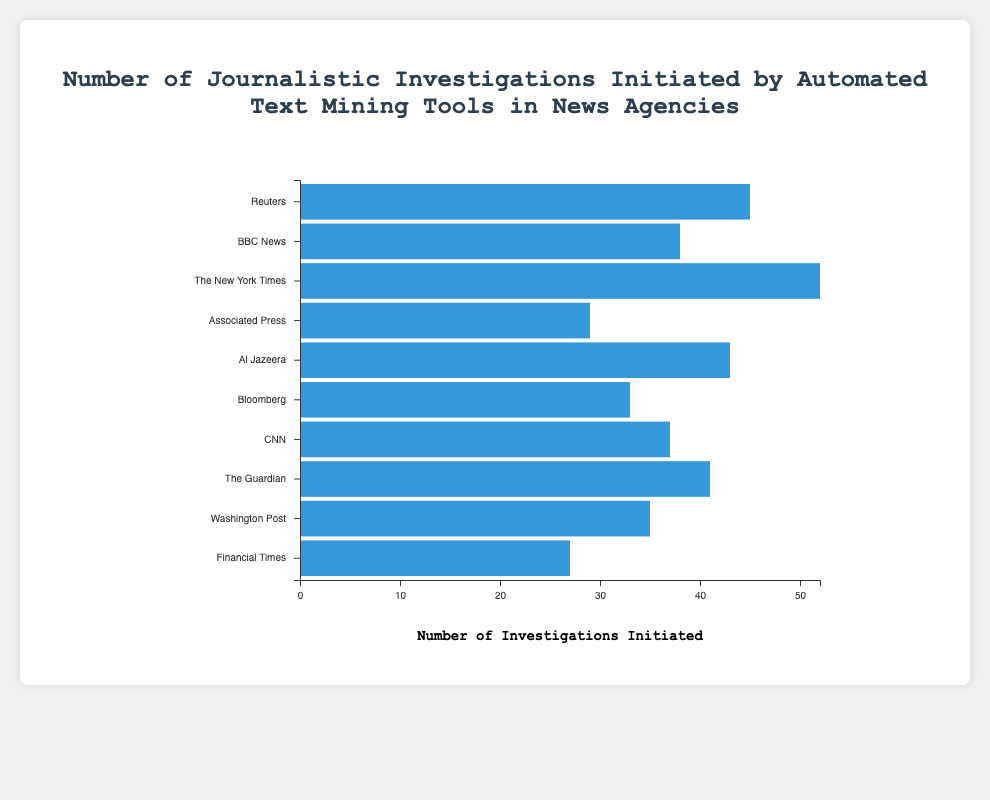How many investigations were initiated by the text mining tool used by The New York Times? According to the chart, "The New York Times" is associated with the text mining tool "SPARK," which initiated 52 investigations.
Answer: 52 Which news agency initiated more investigations using their text mining tool, Reuters or BBC News? The chart shows that Reuters, using "ChronoLink," initiated 45 investigations, while BBC News, using "Leximancer," initiated 38 investigations. Since 45 is greater than 38, Reuters initiated more investigations.
Answer: Reuters What is the difference in the number of investigations initiated by Al Jazeera and the Financial Times? Al Jazeera initiated 43 investigations with "TextRazor," while the Financial Times initiated 27 investigations with "Gavagai." The difference is calculated as 43 - 27 = 16.
Answer: 16 What is the total number of investigations initiated by the top three news agencies in terms of investigations initiated? The top three news agencies based on the number of investigations are The New York Times (52), Reuters (45), and Al Jazeera (43). The total is calculated as 52 + 45 + 43 = 140.
Answer: 140 Which news agency used the "Voyant Tools" text mining tool and how many investigations did it initiate? The chart indicates that The Guardian used "Voyant Tools" and initiated 41 investigations.
Answer: The Guardian, 41 Rank the news agencies in order of the number of investigations initiated from highest to lowest. The ranking based on the number of investigations initiated is: The New York Times (52), Reuters (45), Al Jazeera (43), The Guardian (41), BBC News (38), CNN (37), Washington Post (35), Bloomberg (33), Associated Press (29), Financial Times (27).
Answer: The New York Times > Reuters > Al Jazeera > The Guardian > BBC News > CNN > Washington Post > Bloomberg > Associated Press > Financial Times What is the average number of investigations initiated by all the news agencies? To find the average, sum the total number of investigations initiated by all news agencies and divide by the number of agencies. The total sum is 45 + 38 + 52 + 29 + 43 + 33 + 37 + 41 + 35 + 27 = 380. There are 10 agencies, so the average is 380/10 = 38.
Answer: 38 Which text mining tool initiated the fewest investigations and how many was it? The chart shows that "Gavagai," used by the Financial Times, initiated the fewest investigations with 27.
Answer: Gavagai, 27 